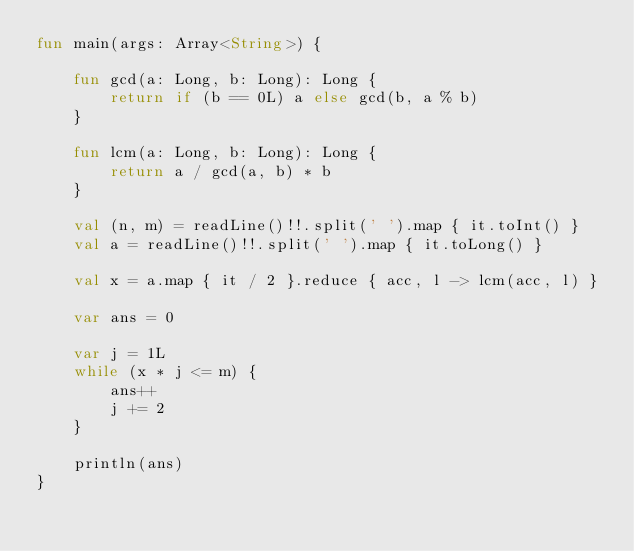<code> <loc_0><loc_0><loc_500><loc_500><_Kotlin_>fun main(args: Array<String>) {

    fun gcd(a: Long, b: Long): Long {
        return if (b == 0L) a else gcd(b, a % b)
    }

    fun lcm(a: Long, b: Long): Long {
        return a / gcd(a, b) * b
    }

    val (n, m) = readLine()!!.split(' ').map { it.toInt() }
    val a = readLine()!!.split(' ').map { it.toLong() }

    val x = a.map { it / 2 }.reduce { acc, l -> lcm(acc, l) }

    var ans = 0

    var j = 1L
    while (x * j <= m) {
        ans++
        j += 2
    }

    println(ans)
}
</code> 